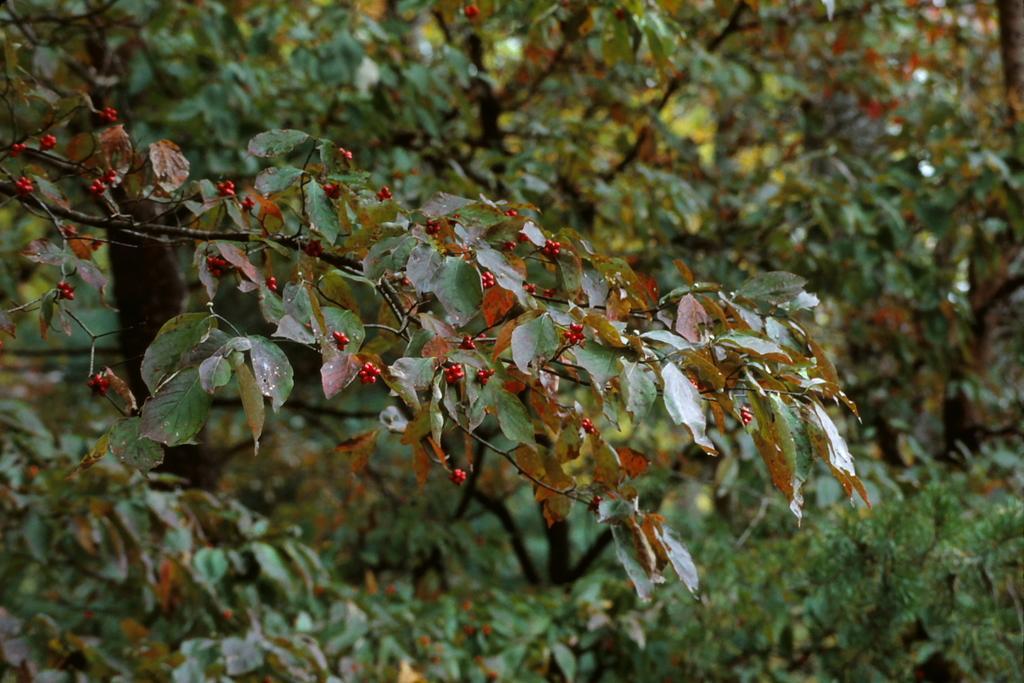Describe this image in one or two sentences. In the center of the image, we can see a stem with berries and leaves and in the background, there are trees. 